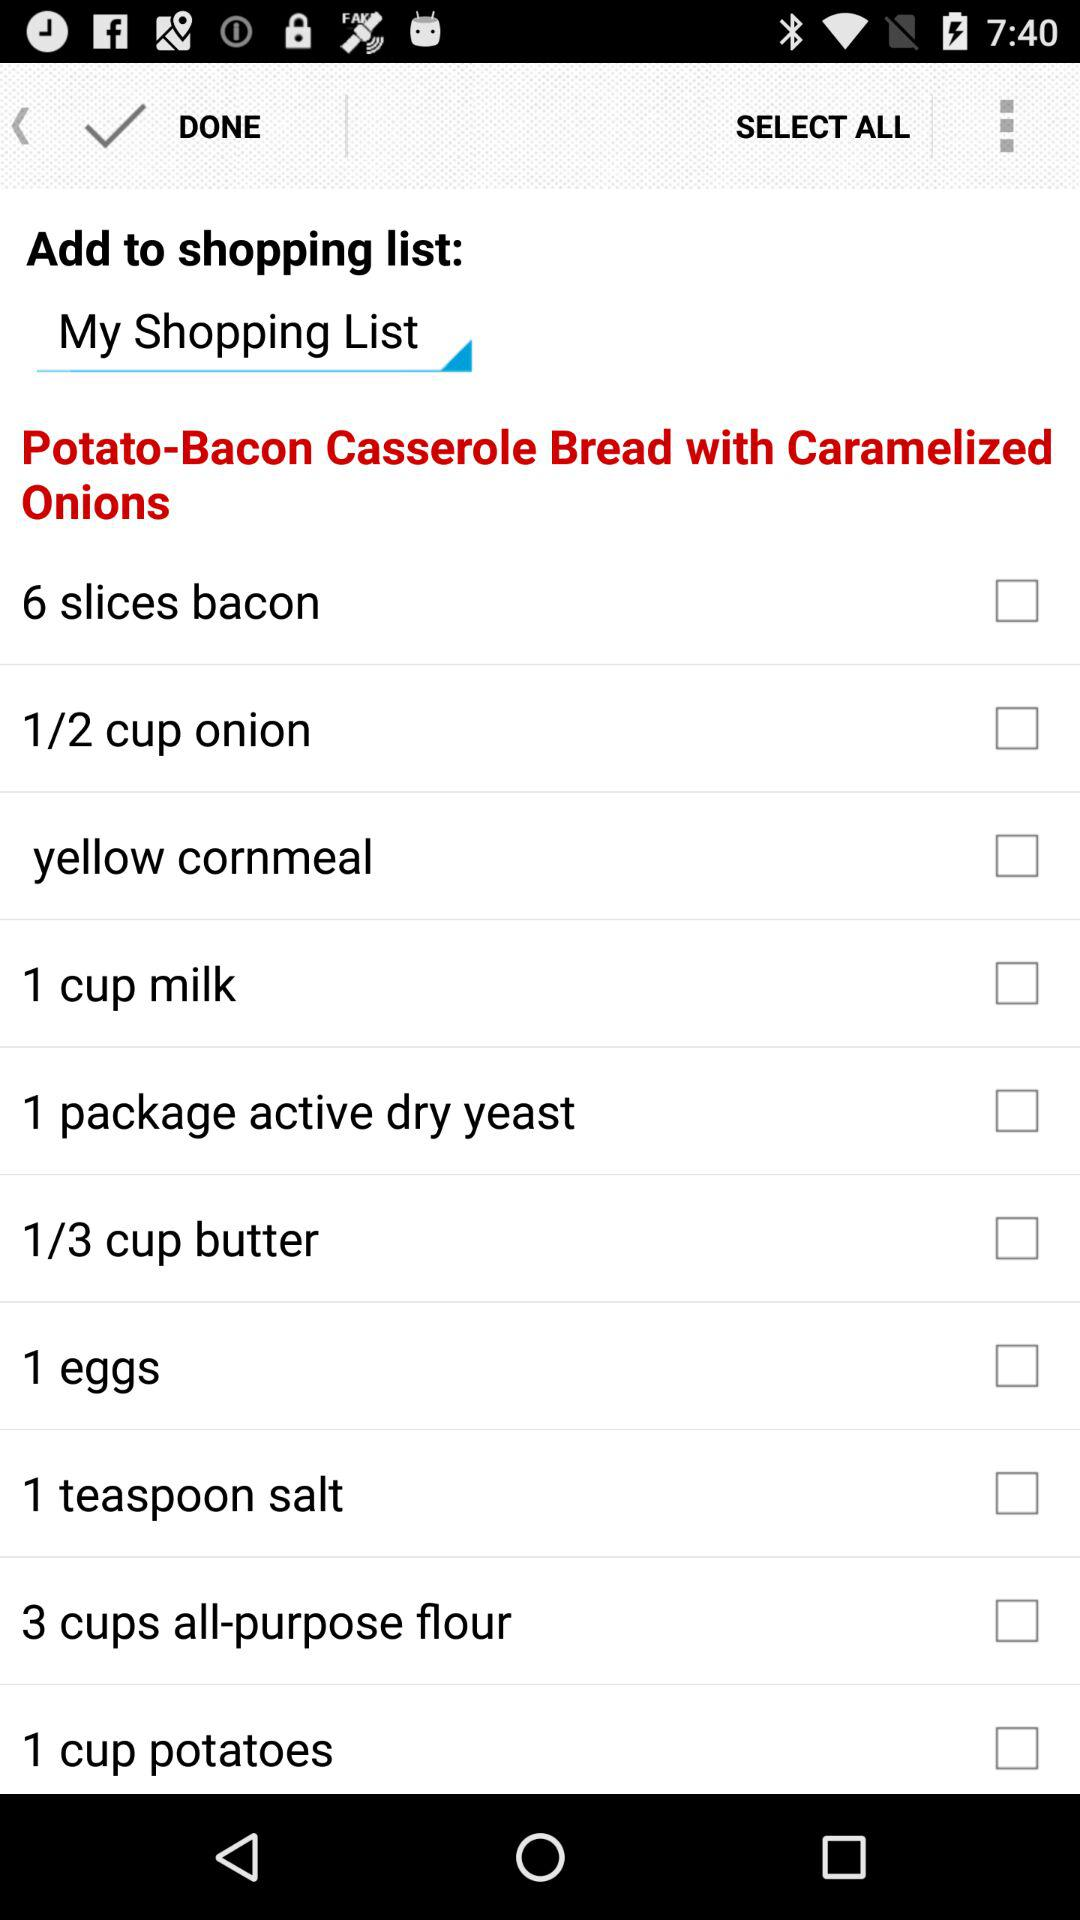How many spoons of salt are needed? The amount of salt needed is 1 teaspoon. 